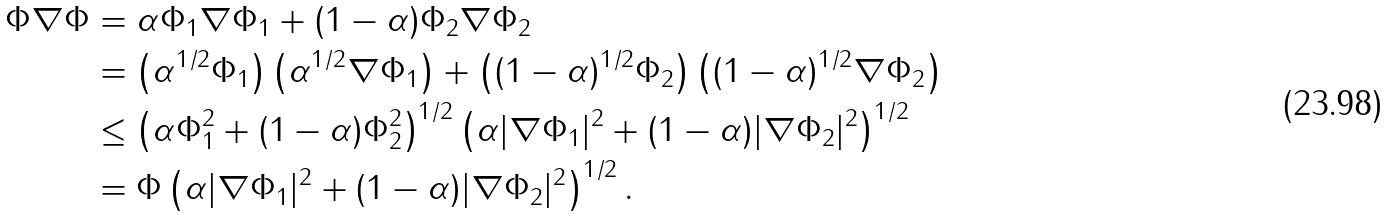Convert formula to latex. <formula><loc_0><loc_0><loc_500><loc_500>\Phi \nabla \Phi & = \alpha \Phi _ { 1 } \nabla \Phi _ { 1 } + ( 1 - \alpha ) \Phi _ { 2 } \nabla \Phi _ { 2 } \\ & = \left ( \alpha ^ { 1 / 2 } \Phi _ { 1 } \right ) \left ( \alpha ^ { 1 / 2 } \nabla \Phi _ { 1 } \right ) + \left ( ( 1 - \alpha ) ^ { 1 / 2 } \Phi _ { 2 } \right ) \left ( ( 1 - \alpha ) ^ { 1 / 2 } \nabla \Phi _ { 2 } \right ) \\ & \leq \left ( \alpha \Phi _ { 1 } ^ { 2 } + ( 1 - \alpha ) \Phi _ { 2 } ^ { 2 } \right ) ^ { 1 / 2 } \left ( \alpha | \nabla \Phi _ { 1 } | ^ { 2 } + ( 1 - \alpha ) | \nabla \Phi _ { 2 } | ^ { 2 } \right ) ^ { 1 / 2 } \\ & = \Phi \left ( \alpha | \nabla \Phi _ { 1 } | ^ { 2 } + ( 1 - \alpha ) | \nabla \Phi _ { 2 } | ^ { 2 } \right ) ^ { 1 / 2 } .</formula> 